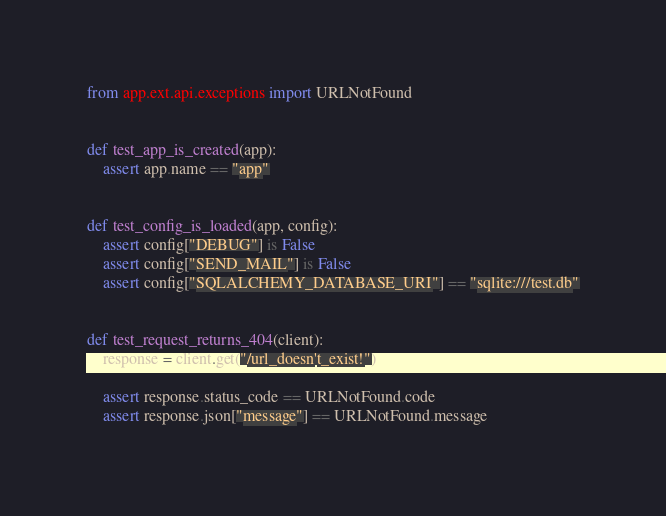Convert code to text. <code><loc_0><loc_0><loc_500><loc_500><_Python_>from app.ext.api.exceptions import URLNotFound


def test_app_is_created(app):
    assert app.name == "app"


def test_config_is_loaded(app, config):
    assert config["DEBUG"] is False
    assert config["SEND_MAIL"] is False
    assert config["SQLALCHEMY_DATABASE_URI"] == "sqlite:///test.db"


def test_request_returns_404(client):
    response = client.get("/url_doesn't_exist!")

    assert response.status_code == URLNotFound.code
    assert response.json["message"] == URLNotFound.message
</code> 